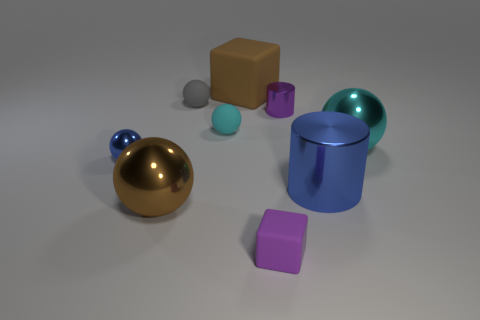Subtract all small balls. How many balls are left? 2 Subtract all purple cubes. How many cyan balls are left? 2 Subtract all gray spheres. How many spheres are left? 4 Subtract 1 balls. How many balls are left? 4 Subtract all spheres. How many objects are left? 4 Subtract all green balls. Subtract all blue cubes. How many balls are left? 5 Subtract all large cyan metallic balls. Subtract all big metal objects. How many objects are left? 5 Add 1 blue metallic balls. How many blue metallic balls are left? 2 Add 3 big cyan metallic spheres. How many big cyan metallic spheres exist? 4 Subtract 0 red blocks. How many objects are left? 9 